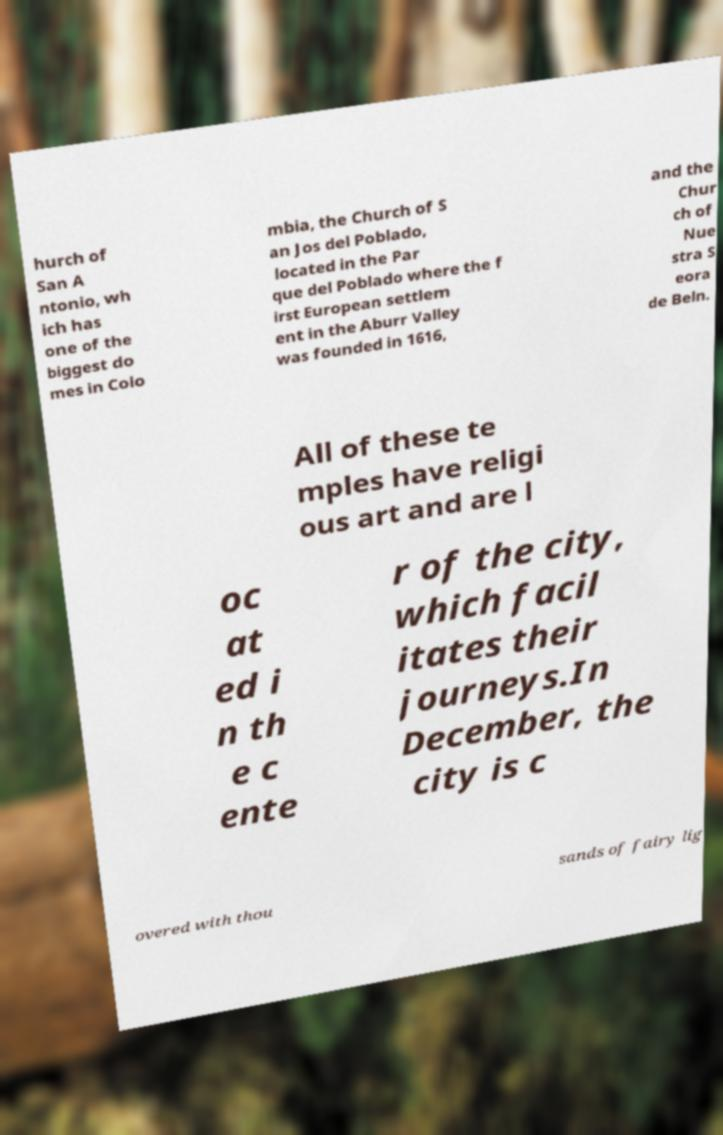For documentation purposes, I need the text within this image transcribed. Could you provide that? hurch of San A ntonio, wh ich has one of the biggest do mes in Colo mbia, the Church of S an Jos del Poblado, located in the Par que del Poblado where the f irst European settlem ent in the Aburr Valley was founded in 1616, and the Chur ch of Nue stra S eora de Beln. All of these te mples have religi ous art and are l oc at ed i n th e c ente r of the city, which facil itates their journeys.In December, the city is c overed with thou sands of fairy lig 